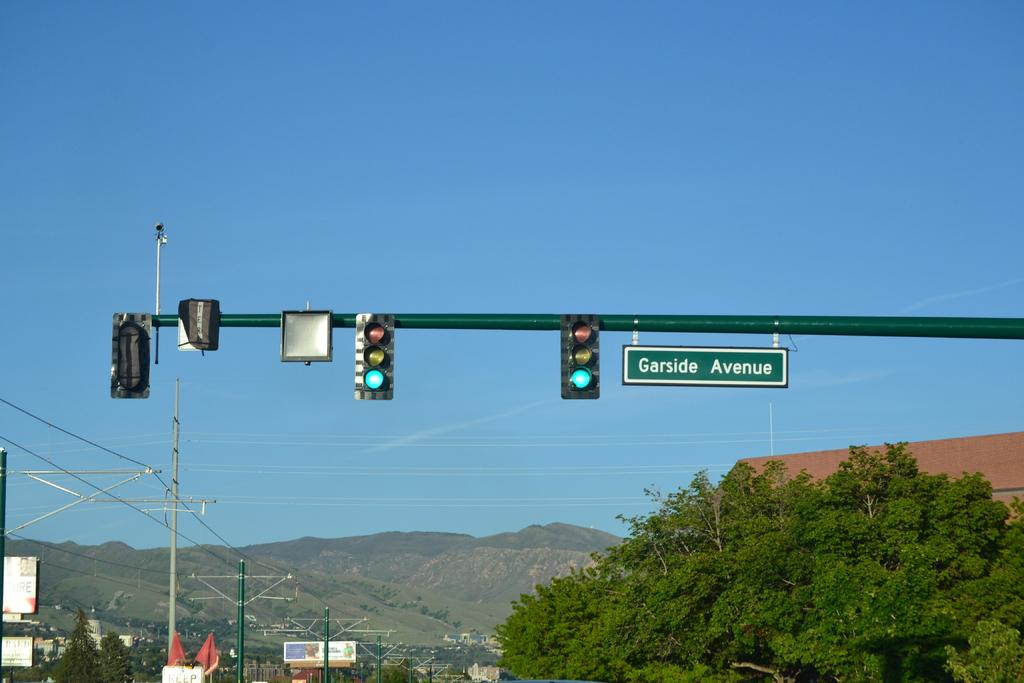<image>
Create a compact narrative representing the image presented. Before you get to the mountains, there's a set of traffic lights at Garside Avenue. 